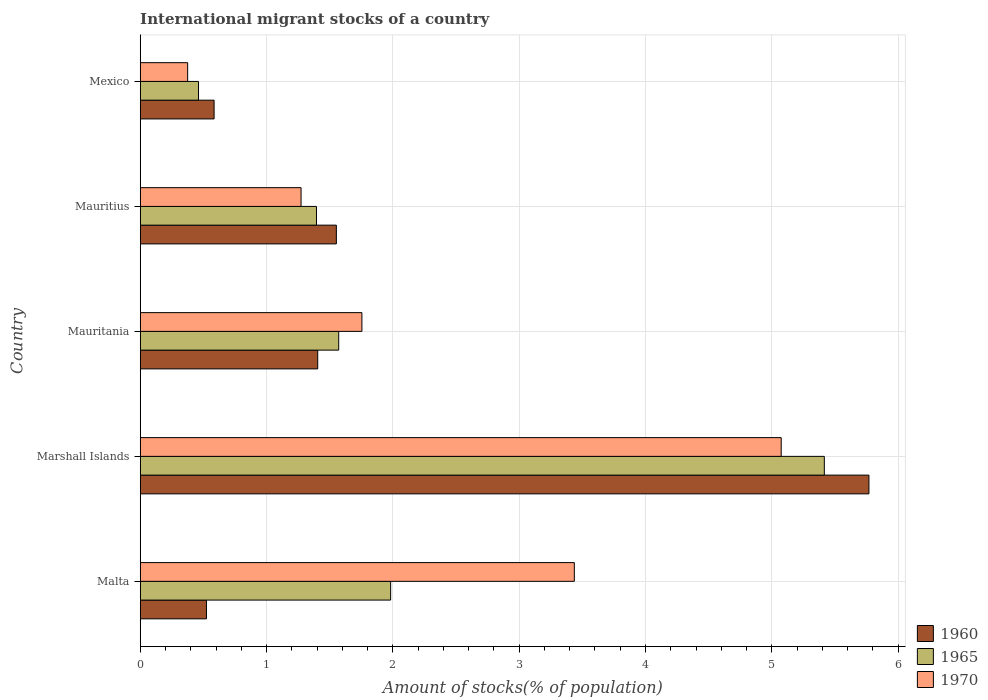How many different coloured bars are there?
Your answer should be compact. 3. Are the number of bars per tick equal to the number of legend labels?
Your answer should be very brief. Yes. Are the number of bars on each tick of the Y-axis equal?
Provide a short and direct response. Yes. How many bars are there on the 2nd tick from the top?
Provide a short and direct response. 3. How many bars are there on the 3rd tick from the bottom?
Provide a short and direct response. 3. What is the label of the 5th group of bars from the top?
Make the answer very short. Malta. What is the amount of stocks in in 1965 in Mauritius?
Ensure brevity in your answer.  1.4. Across all countries, what is the maximum amount of stocks in in 1970?
Your answer should be compact. 5.07. Across all countries, what is the minimum amount of stocks in in 1970?
Keep it short and to the point. 0.38. In which country was the amount of stocks in in 1960 maximum?
Keep it short and to the point. Marshall Islands. What is the total amount of stocks in in 1970 in the graph?
Provide a succinct answer. 11.91. What is the difference between the amount of stocks in in 1965 in Mauritius and that in Mexico?
Offer a terse response. 0.93. What is the difference between the amount of stocks in in 1965 in Marshall Islands and the amount of stocks in in 1970 in Mauritius?
Offer a very short reply. 4.14. What is the average amount of stocks in in 1965 per country?
Your answer should be compact. 2.17. What is the difference between the amount of stocks in in 1970 and amount of stocks in in 1965 in Mauritania?
Ensure brevity in your answer.  0.18. What is the ratio of the amount of stocks in in 1965 in Marshall Islands to that in Mexico?
Give a very brief answer. 11.74. Is the difference between the amount of stocks in in 1970 in Marshall Islands and Mauritania greater than the difference between the amount of stocks in in 1965 in Marshall Islands and Mauritania?
Your answer should be very brief. No. What is the difference between the highest and the second highest amount of stocks in in 1960?
Offer a very short reply. 4.22. What is the difference between the highest and the lowest amount of stocks in in 1965?
Make the answer very short. 4.95. In how many countries, is the amount of stocks in in 1965 greater than the average amount of stocks in in 1965 taken over all countries?
Ensure brevity in your answer.  1. Is the sum of the amount of stocks in in 1960 in Malta and Mexico greater than the maximum amount of stocks in in 1965 across all countries?
Make the answer very short. No. What does the 2nd bar from the top in Mauritius represents?
Offer a very short reply. 1965. How many countries are there in the graph?
Your answer should be compact. 5. What is the difference between two consecutive major ticks on the X-axis?
Provide a short and direct response. 1. Are the values on the major ticks of X-axis written in scientific E-notation?
Ensure brevity in your answer.  No. Where does the legend appear in the graph?
Ensure brevity in your answer.  Bottom right. How are the legend labels stacked?
Offer a very short reply. Vertical. What is the title of the graph?
Your answer should be compact. International migrant stocks of a country. Does "1965" appear as one of the legend labels in the graph?
Your answer should be compact. Yes. What is the label or title of the X-axis?
Your response must be concise. Amount of stocks(% of population). What is the label or title of the Y-axis?
Your answer should be very brief. Country. What is the Amount of stocks(% of population) of 1960 in Malta?
Your answer should be compact. 0.52. What is the Amount of stocks(% of population) of 1965 in Malta?
Ensure brevity in your answer.  1.98. What is the Amount of stocks(% of population) of 1970 in Malta?
Your response must be concise. 3.44. What is the Amount of stocks(% of population) in 1960 in Marshall Islands?
Provide a short and direct response. 5.77. What is the Amount of stocks(% of population) of 1965 in Marshall Islands?
Provide a short and direct response. 5.42. What is the Amount of stocks(% of population) of 1970 in Marshall Islands?
Your answer should be very brief. 5.07. What is the Amount of stocks(% of population) in 1960 in Mauritania?
Make the answer very short. 1.41. What is the Amount of stocks(% of population) in 1965 in Mauritania?
Your response must be concise. 1.57. What is the Amount of stocks(% of population) of 1970 in Mauritania?
Your answer should be very brief. 1.75. What is the Amount of stocks(% of population) in 1960 in Mauritius?
Offer a terse response. 1.55. What is the Amount of stocks(% of population) of 1965 in Mauritius?
Your answer should be compact. 1.4. What is the Amount of stocks(% of population) of 1970 in Mauritius?
Give a very brief answer. 1.27. What is the Amount of stocks(% of population) of 1960 in Mexico?
Your answer should be compact. 0.58. What is the Amount of stocks(% of population) of 1965 in Mexico?
Your answer should be very brief. 0.46. What is the Amount of stocks(% of population) in 1970 in Mexico?
Provide a succinct answer. 0.38. Across all countries, what is the maximum Amount of stocks(% of population) of 1960?
Your answer should be compact. 5.77. Across all countries, what is the maximum Amount of stocks(% of population) in 1965?
Make the answer very short. 5.42. Across all countries, what is the maximum Amount of stocks(% of population) in 1970?
Make the answer very short. 5.07. Across all countries, what is the minimum Amount of stocks(% of population) of 1960?
Provide a short and direct response. 0.52. Across all countries, what is the minimum Amount of stocks(% of population) in 1965?
Offer a terse response. 0.46. Across all countries, what is the minimum Amount of stocks(% of population) in 1970?
Give a very brief answer. 0.38. What is the total Amount of stocks(% of population) in 1960 in the graph?
Your answer should be very brief. 9.84. What is the total Amount of stocks(% of population) in 1965 in the graph?
Your response must be concise. 10.83. What is the total Amount of stocks(% of population) of 1970 in the graph?
Make the answer very short. 11.91. What is the difference between the Amount of stocks(% of population) in 1960 in Malta and that in Marshall Islands?
Provide a succinct answer. -5.24. What is the difference between the Amount of stocks(% of population) of 1965 in Malta and that in Marshall Islands?
Keep it short and to the point. -3.43. What is the difference between the Amount of stocks(% of population) in 1970 in Malta and that in Marshall Islands?
Your answer should be very brief. -1.64. What is the difference between the Amount of stocks(% of population) of 1960 in Malta and that in Mauritania?
Keep it short and to the point. -0.88. What is the difference between the Amount of stocks(% of population) of 1965 in Malta and that in Mauritania?
Make the answer very short. 0.41. What is the difference between the Amount of stocks(% of population) of 1970 in Malta and that in Mauritania?
Your answer should be very brief. 1.68. What is the difference between the Amount of stocks(% of population) in 1960 in Malta and that in Mauritius?
Offer a terse response. -1.03. What is the difference between the Amount of stocks(% of population) in 1965 in Malta and that in Mauritius?
Keep it short and to the point. 0.59. What is the difference between the Amount of stocks(% of population) in 1970 in Malta and that in Mauritius?
Provide a short and direct response. 2.16. What is the difference between the Amount of stocks(% of population) in 1960 in Malta and that in Mexico?
Ensure brevity in your answer.  -0.06. What is the difference between the Amount of stocks(% of population) of 1965 in Malta and that in Mexico?
Ensure brevity in your answer.  1.52. What is the difference between the Amount of stocks(% of population) in 1970 in Malta and that in Mexico?
Offer a terse response. 3.06. What is the difference between the Amount of stocks(% of population) in 1960 in Marshall Islands and that in Mauritania?
Your response must be concise. 4.36. What is the difference between the Amount of stocks(% of population) of 1965 in Marshall Islands and that in Mauritania?
Offer a terse response. 3.84. What is the difference between the Amount of stocks(% of population) of 1970 in Marshall Islands and that in Mauritania?
Ensure brevity in your answer.  3.32. What is the difference between the Amount of stocks(% of population) of 1960 in Marshall Islands and that in Mauritius?
Your answer should be very brief. 4.22. What is the difference between the Amount of stocks(% of population) of 1965 in Marshall Islands and that in Mauritius?
Ensure brevity in your answer.  4.02. What is the difference between the Amount of stocks(% of population) in 1970 in Marshall Islands and that in Mauritius?
Provide a succinct answer. 3.8. What is the difference between the Amount of stocks(% of population) in 1960 in Marshall Islands and that in Mexico?
Keep it short and to the point. 5.18. What is the difference between the Amount of stocks(% of population) in 1965 in Marshall Islands and that in Mexico?
Your answer should be compact. 4.95. What is the difference between the Amount of stocks(% of population) of 1970 in Marshall Islands and that in Mexico?
Provide a short and direct response. 4.7. What is the difference between the Amount of stocks(% of population) in 1960 in Mauritania and that in Mauritius?
Give a very brief answer. -0.15. What is the difference between the Amount of stocks(% of population) of 1965 in Mauritania and that in Mauritius?
Offer a very short reply. 0.18. What is the difference between the Amount of stocks(% of population) in 1970 in Mauritania and that in Mauritius?
Give a very brief answer. 0.48. What is the difference between the Amount of stocks(% of population) of 1960 in Mauritania and that in Mexico?
Ensure brevity in your answer.  0.82. What is the difference between the Amount of stocks(% of population) in 1965 in Mauritania and that in Mexico?
Your answer should be very brief. 1.11. What is the difference between the Amount of stocks(% of population) of 1970 in Mauritania and that in Mexico?
Offer a very short reply. 1.38. What is the difference between the Amount of stocks(% of population) in 1960 in Mauritius and that in Mexico?
Ensure brevity in your answer.  0.97. What is the difference between the Amount of stocks(% of population) in 1965 in Mauritius and that in Mexico?
Provide a succinct answer. 0.93. What is the difference between the Amount of stocks(% of population) in 1970 in Mauritius and that in Mexico?
Keep it short and to the point. 0.9. What is the difference between the Amount of stocks(% of population) in 1960 in Malta and the Amount of stocks(% of population) in 1965 in Marshall Islands?
Provide a succinct answer. -4.89. What is the difference between the Amount of stocks(% of population) of 1960 in Malta and the Amount of stocks(% of population) of 1970 in Marshall Islands?
Give a very brief answer. -4.55. What is the difference between the Amount of stocks(% of population) in 1965 in Malta and the Amount of stocks(% of population) in 1970 in Marshall Islands?
Your answer should be very brief. -3.09. What is the difference between the Amount of stocks(% of population) of 1960 in Malta and the Amount of stocks(% of population) of 1965 in Mauritania?
Provide a short and direct response. -1.05. What is the difference between the Amount of stocks(% of population) of 1960 in Malta and the Amount of stocks(% of population) of 1970 in Mauritania?
Your answer should be compact. -1.23. What is the difference between the Amount of stocks(% of population) in 1965 in Malta and the Amount of stocks(% of population) in 1970 in Mauritania?
Offer a very short reply. 0.23. What is the difference between the Amount of stocks(% of population) in 1960 in Malta and the Amount of stocks(% of population) in 1965 in Mauritius?
Your response must be concise. -0.87. What is the difference between the Amount of stocks(% of population) in 1960 in Malta and the Amount of stocks(% of population) in 1970 in Mauritius?
Ensure brevity in your answer.  -0.75. What is the difference between the Amount of stocks(% of population) of 1965 in Malta and the Amount of stocks(% of population) of 1970 in Mauritius?
Offer a very short reply. 0.71. What is the difference between the Amount of stocks(% of population) in 1960 in Malta and the Amount of stocks(% of population) in 1965 in Mexico?
Offer a terse response. 0.06. What is the difference between the Amount of stocks(% of population) in 1960 in Malta and the Amount of stocks(% of population) in 1970 in Mexico?
Your answer should be compact. 0.15. What is the difference between the Amount of stocks(% of population) of 1965 in Malta and the Amount of stocks(% of population) of 1970 in Mexico?
Provide a short and direct response. 1.61. What is the difference between the Amount of stocks(% of population) of 1960 in Marshall Islands and the Amount of stocks(% of population) of 1965 in Mauritania?
Offer a very short reply. 4.2. What is the difference between the Amount of stocks(% of population) in 1960 in Marshall Islands and the Amount of stocks(% of population) in 1970 in Mauritania?
Ensure brevity in your answer.  4.01. What is the difference between the Amount of stocks(% of population) in 1965 in Marshall Islands and the Amount of stocks(% of population) in 1970 in Mauritania?
Keep it short and to the point. 3.66. What is the difference between the Amount of stocks(% of population) of 1960 in Marshall Islands and the Amount of stocks(% of population) of 1965 in Mauritius?
Your answer should be very brief. 4.37. What is the difference between the Amount of stocks(% of population) of 1960 in Marshall Islands and the Amount of stocks(% of population) of 1970 in Mauritius?
Offer a very short reply. 4.5. What is the difference between the Amount of stocks(% of population) in 1965 in Marshall Islands and the Amount of stocks(% of population) in 1970 in Mauritius?
Provide a succinct answer. 4.14. What is the difference between the Amount of stocks(% of population) of 1960 in Marshall Islands and the Amount of stocks(% of population) of 1965 in Mexico?
Your answer should be compact. 5.31. What is the difference between the Amount of stocks(% of population) of 1960 in Marshall Islands and the Amount of stocks(% of population) of 1970 in Mexico?
Offer a terse response. 5.39. What is the difference between the Amount of stocks(% of population) in 1965 in Marshall Islands and the Amount of stocks(% of population) in 1970 in Mexico?
Offer a very short reply. 5.04. What is the difference between the Amount of stocks(% of population) of 1960 in Mauritania and the Amount of stocks(% of population) of 1965 in Mauritius?
Your answer should be compact. 0.01. What is the difference between the Amount of stocks(% of population) in 1960 in Mauritania and the Amount of stocks(% of population) in 1970 in Mauritius?
Your response must be concise. 0.13. What is the difference between the Amount of stocks(% of population) in 1965 in Mauritania and the Amount of stocks(% of population) in 1970 in Mauritius?
Make the answer very short. 0.3. What is the difference between the Amount of stocks(% of population) of 1960 in Mauritania and the Amount of stocks(% of population) of 1965 in Mexico?
Keep it short and to the point. 0.94. What is the difference between the Amount of stocks(% of population) in 1960 in Mauritania and the Amount of stocks(% of population) in 1970 in Mexico?
Ensure brevity in your answer.  1.03. What is the difference between the Amount of stocks(% of population) in 1965 in Mauritania and the Amount of stocks(% of population) in 1970 in Mexico?
Offer a terse response. 1.2. What is the difference between the Amount of stocks(% of population) of 1960 in Mauritius and the Amount of stocks(% of population) of 1965 in Mexico?
Offer a very short reply. 1.09. What is the difference between the Amount of stocks(% of population) of 1960 in Mauritius and the Amount of stocks(% of population) of 1970 in Mexico?
Your answer should be very brief. 1.18. What is the difference between the Amount of stocks(% of population) of 1965 in Mauritius and the Amount of stocks(% of population) of 1970 in Mexico?
Make the answer very short. 1.02. What is the average Amount of stocks(% of population) of 1960 per country?
Ensure brevity in your answer.  1.97. What is the average Amount of stocks(% of population) in 1965 per country?
Your response must be concise. 2.17. What is the average Amount of stocks(% of population) in 1970 per country?
Give a very brief answer. 2.38. What is the difference between the Amount of stocks(% of population) in 1960 and Amount of stocks(% of population) in 1965 in Malta?
Ensure brevity in your answer.  -1.46. What is the difference between the Amount of stocks(% of population) of 1960 and Amount of stocks(% of population) of 1970 in Malta?
Your answer should be very brief. -2.91. What is the difference between the Amount of stocks(% of population) in 1965 and Amount of stocks(% of population) in 1970 in Malta?
Ensure brevity in your answer.  -1.45. What is the difference between the Amount of stocks(% of population) in 1960 and Amount of stocks(% of population) in 1965 in Marshall Islands?
Make the answer very short. 0.35. What is the difference between the Amount of stocks(% of population) of 1960 and Amount of stocks(% of population) of 1970 in Marshall Islands?
Offer a very short reply. 0.69. What is the difference between the Amount of stocks(% of population) in 1965 and Amount of stocks(% of population) in 1970 in Marshall Islands?
Your answer should be very brief. 0.34. What is the difference between the Amount of stocks(% of population) of 1960 and Amount of stocks(% of population) of 1965 in Mauritania?
Provide a succinct answer. -0.17. What is the difference between the Amount of stocks(% of population) of 1960 and Amount of stocks(% of population) of 1970 in Mauritania?
Give a very brief answer. -0.35. What is the difference between the Amount of stocks(% of population) of 1965 and Amount of stocks(% of population) of 1970 in Mauritania?
Offer a terse response. -0.18. What is the difference between the Amount of stocks(% of population) in 1960 and Amount of stocks(% of population) in 1965 in Mauritius?
Your response must be concise. 0.16. What is the difference between the Amount of stocks(% of population) in 1960 and Amount of stocks(% of population) in 1970 in Mauritius?
Provide a short and direct response. 0.28. What is the difference between the Amount of stocks(% of population) in 1965 and Amount of stocks(% of population) in 1970 in Mauritius?
Offer a very short reply. 0.12. What is the difference between the Amount of stocks(% of population) of 1960 and Amount of stocks(% of population) of 1965 in Mexico?
Keep it short and to the point. 0.12. What is the difference between the Amount of stocks(% of population) of 1960 and Amount of stocks(% of population) of 1970 in Mexico?
Ensure brevity in your answer.  0.21. What is the difference between the Amount of stocks(% of population) in 1965 and Amount of stocks(% of population) in 1970 in Mexico?
Your answer should be very brief. 0.09. What is the ratio of the Amount of stocks(% of population) in 1960 in Malta to that in Marshall Islands?
Provide a succinct answer. 0.09. What is the ratio of the Amount of stocks(% of population) of 1965 in Malta to that in Marshall Islands?
Offer a terse response. 0.37. What is the ratio of the Amount of stocks(% of population) in 1970 in Malta to that in Marshall Islands?
Make the answer very short. 0.68. What is the ratio of the Amount of stocks(% of population) of 1960 in Malta to that in Mauritania?
Provide a succinct answer. 0.37. What is the ratio of the Amount of stocks(% of population) of 1965 in Malta to that in Mauritania?
Keep it short and to the point. 1.26. What is the ratio of the Amount of stocks(% of population) of 1970 in Malta to that in Mauritania?
Your answer should be compact. 1.96. What is the ratio of the Amount of stocks(% of population) in 1960 in Malta to that in Mauritius?
Provide a short and direct response. 0.34. What is the ratio of the Amount of stocks(% of population) in 1965 in Malta to that in Mauritius?
Your answer should be very brief. 1.42. What is the ratio of the Amount of stocks(% of population) in 1970 in Malta to that in Mauritius?
Keep it short and to the point. 2.7. What is the ratio of the Amount of stocks(% of population) of 1960 in Malta to that in Mexico?
Your answer should be very brief. 0.9. What is the ratio of the Amount of stocks(% of population) in 1965 in Malta to that in Mexico?
Keep it short and to the point. 4.3. What is the ratio of the Amount of stocks(% of population) of 1970 in Malta to that in Mexico?
Your answer should be very brief. 9.15. What is the ratio of the Amount of stocks(% of population) of 1960 in Marshall Islands to that in Mauritania?
Provide a succinct answer. 4.11. What is the ratio of the Amount of stocks(% of population) in 1965 in Marshall Islands to that in Mauritania?
Your response must be concise. 3.45. What is the ratio of the Amount of stocks(% of population) in 1970 in Marshall Islands to that in Mauritania?
Make the answer very short. 2.89. What is the ratio of the Amount of stocks(% of population) in 1960 in Marshall Islands to that in Mauritius?
Make the answer very short. 3.72. What is the ratio of the Amount of stocks(% of population) of 1965 in Marshall Islands to that in Mauritius?
Offer a very short reply. 3.88. What is the ratio of the Amount of stocks(% of population) of 1970 in Marshall Islands to that in Mauritius?
Provide a succinct answer. 3.99. What is the ratio of the Amount of stocks(% of population) in 1960 in Marshall Islands to that in Mexico?
Make the answer very short. 9.86. What is the ratio of the Amount of stocks(% of population) in 1965 in Marshall Islands to that in Mexico?
Ensure brevity in your answer.  11.74. What is the ratio of the Amount of stocks(% of population) in 1970 in Marshall Islands to that in Mexico?
Your answer should be very brief. 13.51. What is the ratio of the Amount of stocks(% of population) of 1960 in Mauritania to that in Mauritius?
Provide a succinct answer. 0.9. What is the ratio of the Amount of stocks(% of population) in 1965 in Mauritania to that in Mauritius?
Offer a very short reply. 1.13. What is the ratio of the Amount of stocks(% of population) in 1970 in Mauritania to that in Mauritius?
Offer a very short reply. 1.38. What is the ratio of the Amount of stocks(% of population) in 1960 in Mauritania to that in Mexico?
Make the answer very short. 2.4. What is the ratio of the Amount of stocks(% of population) of 1965 in Mauritania to that in Mexico?
Offer a terse response. 3.41. What is the ratio of the Amount of stocks(% of population) of 1970 in Mauritania to that in Mexico?
Make the answer very short. 4.67. What is the ratio of the Amount of stocks(% of population) of 1960 in Mauritius to that in Mexico?
Offer a terse response. 2.66. What is the ratio of the Amount of stocks(% of population) in 1965 in Mauritius to that in Mexico?
Your response must be concise. 3.02. What is the ratio of the Amount of stocks(% of population) of 1970 in Mauritius to that in Mexico?
Ensure brevity in your answer.  3.39. What is the difference between the highest and the second highest Amount of stocks(% of population) of 1960?
Ensure brevity in your answer.  4.22. What is the difference between the highest and the second highest Amount of stocks(% of population) of 1965?
Your response must be concise. 3.43. What is the difference between the highest and the second highest Amount of stocks(% of population) of 1970?
Offer a very short reply. 1.64. What is the difference between the highest and the lowest Amount of stocks(% of population) in 1960?
Offer a terse response. 5.24. What is the difference between the highest and the lowest Amount of stocks(% of population) of 1965?
Your answer should be compact. 4.95. What is the difference between the highest and the lowest Amount of stocks(% of population) in 1970?
Give a very brief answer. 4.7. 